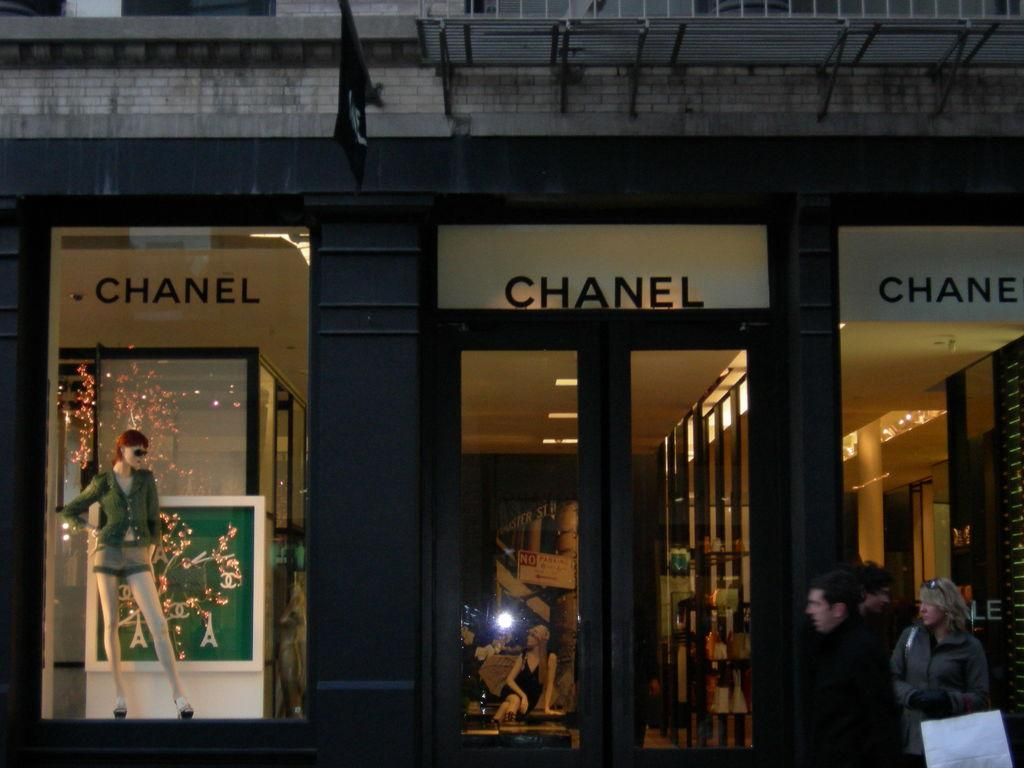Who or what can be seen in the image? There are people in the image. What type of structure is present in the image? There is a wall in the image. What feature allows for visibility between the inside and outside of the structure? There is a glass door in the image. Are there any other transparent elements in the image? Yes, there are glass windows in the image. What can be seen through one of the glass windows? A mannequin is visible through the glass window. What type of iron is being used to create the machine's order in the image? There is no iron or machine present in the image, and therefore no such activity can be observed. 